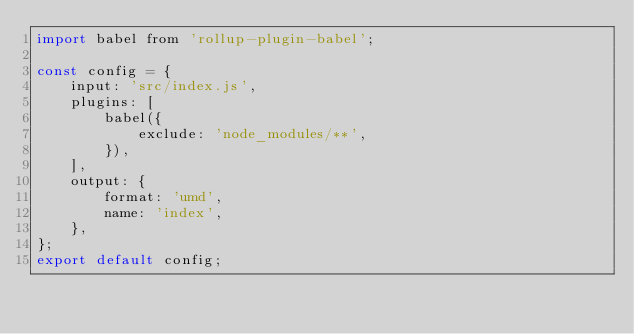<code> <loc_0><loc_0><loc_500><loc_500><_JavaScript_>import babel from 'rollup-plugin-babel';

const config = {
    input: 'src/index.js',
    plugins: [
        babel({
            exclude: 'node_modules/**',
        }),
    ],
    output: {
        format: 'umd',
        name: 'index',
    },
};
export default config;</code> 